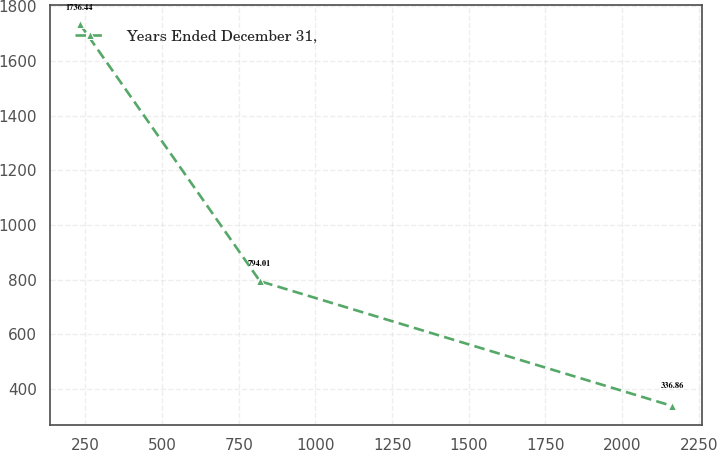Convert chart. <chart><loc_0><loc_0><loc_500><loc_500><line_chart><ecel><fcel>Years Ended December 31,<nl><fcel>231.22<fcel>1736.44<nl><fcel>818.96<fcel>794.01<nl><fcel>2163.98<fcel>336.86<nl></chart> 